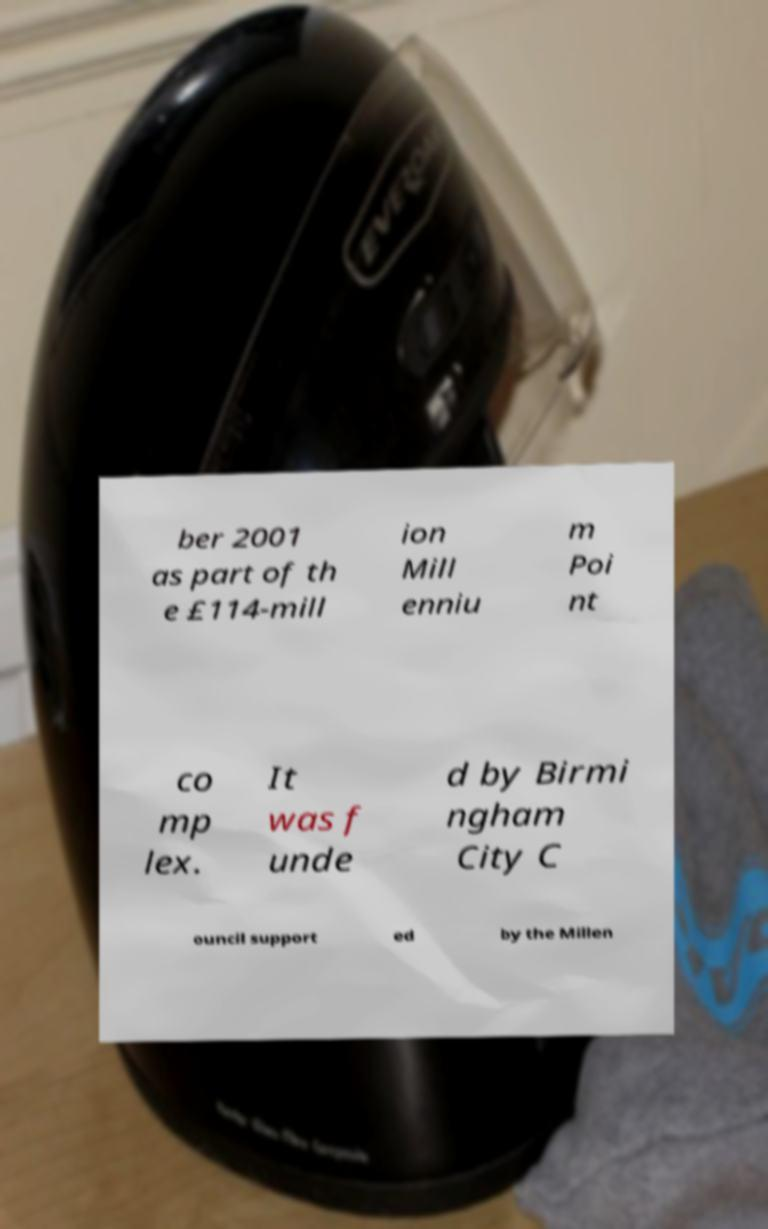Could you extract and type out the text from this image? ber 2001 as part of th e £114-mill ion Mill enniu m Poi nt co mp lex. It was f unde d by Birmi ngham City C ouncil support ed by the Millen 